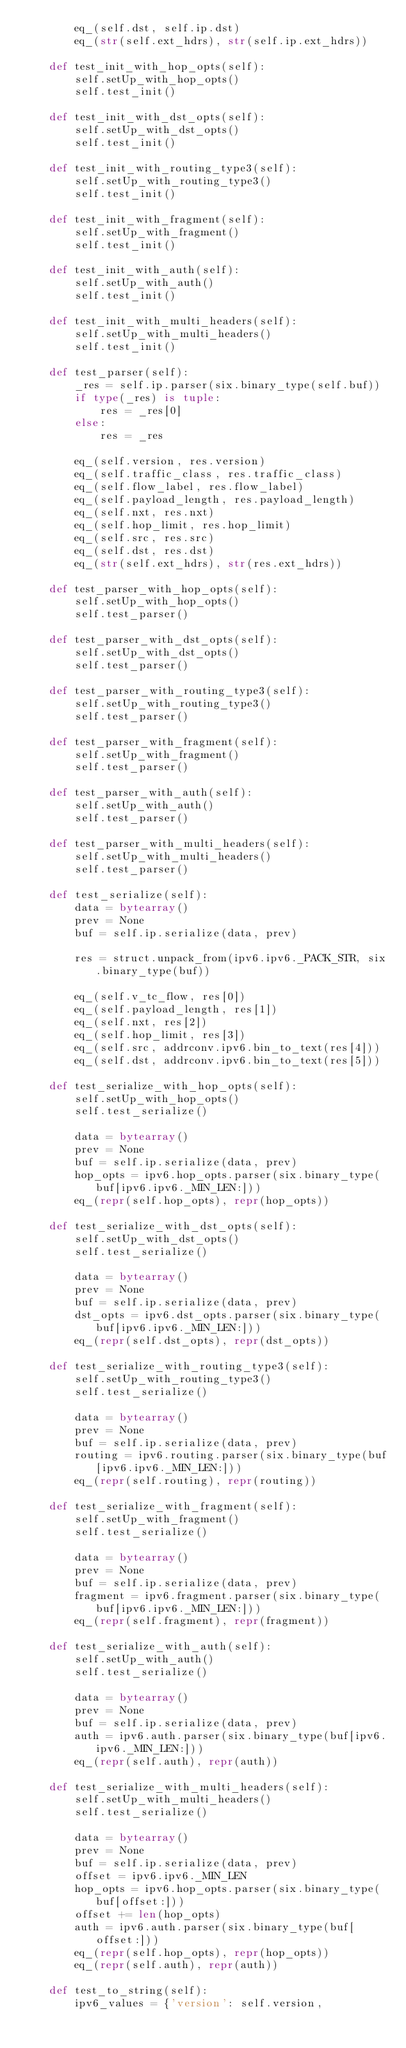<code> <loc_0><loc_0><loc_500><loc_500><_Python_>        eq_(self.dst, self.ip.dst)
        eq_(str(self.ext_hdrs), str(self.ip.ext_hdrs))

    def test_init_with_hop_opts(self):
        self.setUp_with_hop_opts()
        self.test_init()

    def test_init_with_dst_opts(self):
        self.setUp_with_dst_opts()
        self.test_init()

    def test_init_with_routing_type3(self):
        self.setUp_with_routing_type3()
        self.test_init()

    def test_init_with_fragment(self):
        self.setUp_with_fragment()
        self.test_init()

    def test_init_with_auth(self):
        self.setUp_with_auth()
        self.test_init()

    def test_init_with_multi_headers(self):
        self.setUp_with_multi_headers()
        self.test_init()

    def test_parser(self):
        _res = self.ip.parser(six.binary_type(self.buf))
        if type(_res) is tuple:
            res = _res[0]
        else:
            res = _res

        eq_(self.version, res.version)
        eq_(self.traffic_class, res.traffic_class)
        eq_(self.flow_label, res.flow_label)
        eq_(self.payload_length, res.payload_length)
        eq_(self.nxt, res.nxt)
        eq_(self.hop_limit, res.hop_limit)
        eq_(self.src, res.src)
        eq_(self.dst, res.dst)
        eq_(str(self.ext_hdrs), str(res.ext_hdrs))

    def test_parser_with_hop_opts(self):
        self.setUp_with_hop_opts()
        self.test_parser()

    def test_parser_with_dst_opts(self):
        self.setUp_with_dst_opts()
        self.test_parser()

    def test_parser_with_routing_type3(self):
        self.setUp_with_routing_type3()
        self.test_parser()

    def test_parser_with_fragment(self):
        self.setUp_with_fragment()
        self.test_parser()

    def test_parser_with_auth(self):
        self.setUp_with_auth()
        self.test_parser()

    def test_parser_with_multi_headers(self):
        self.setUp_with_multi_headers()
        self.test_parser()

    def test_serialize(self):
        data = bytearray()
        prev = None
        buf = self.ip.serialize(data, prev)

        res = struct.unpack_from(ipv6.ipv6._PACK_STR, six.binary_type(buf))

        eq_(self.v_tc_flow, res[0])
        eq_(self.payload_length, res[1])
        eq_(self.nxt, res[2])
        eq_(self.hop_limit, res[3])
        eq_(self.src, addrconv.ipv6.bin_to_text(res[4]))
        eq_(self.dst, addrconv.ipv6.bin_to_text(res[5]))

    def test_serialize_with_hop_opts(self):
        self.setUp_with_hop_opts()
        self.test_serialize()

        data = bytearray()
        prev = None
        buf = self.ip.serialize(data, prev)
        hop_opts = ipv6.hop_opts.parser(six.binary_type(buf[ipv6.ipv6._MIN_LEN:]))
        eq_(repr(self.hop_opts), repr(hop_opts))

    def test_serialize_with_dst_opts(self):
        self.setUp_with_dst_opts()
        self.test_serialize()

        data = bytearray()
        prev = None
        buf = self.ip.serialize(data, prev)
        dst_opts = ipv6.dst_opts.parser(six.binary_type(buf[ipv6.ipv6._MIN_LEN:]))
        eq_(repr(self.dst_opts), repr(dst_opts))

    def test_serialize_with_routing_type3(self):
        self.setUp_with_routing_type3()
        self.test_serialize()

        data = bytearray()
        prev = None
        buf = self.ip.serialize(data, prev)
        routing = ipv6.routing.parser(six.binary_type(buf[ipv6.ipv6._MIN_LEN:]))
        eq_(repr(self.routing), repr(routing))

    def test_serialize_with_fragment(self):
        self.setUp_with_fragment()
        self.test_serialize()

        data = bytearray()
        prev = None
        buf = self.ip.serialize(data, prev)
        fragment = ipv6.fragment.parser(six.binary_type(buf[ipv6.ipv6._MIN_LEN:]))
        eq_(repr(self.fragment), repr(fragment))

    def test_serialize_with_auth(self):
        self.setUp_with_auth()
        self.test_serialize()

        data = bytearray()
        prev = None
        buf = self.ip.serialize(data, prev)
        auth = ipv6.auth.parser(six.binary_type(buf[ipv6.ipv6._MIN_LEN:]))
        eq_(repr(self.auth), repr(auth))

    def test_serialize_with_multi_headers(self):
        self.setUp_with_multi_headers()
        self.test_serialize()

        data = bytearray()
        prev = None
        buf = self.ip.serialize(data, prev)
        offset = ipv6.ipv6._MIN_LEN
        hop_opts = ipv6.hop_opts.parser(six.binary_type(buf[offset:]))
        offset += len(hop_opts)
        auth = ipv6.auth.parser(six.binary_type(buf[offset:]))
        eq_(repr(self.hop_opts), repr(hop_opts))
        eq_(repr(self.auth), repr(auth))

    def test_to_string(self):
        ipv6_values = {'version': self.version,</code> 